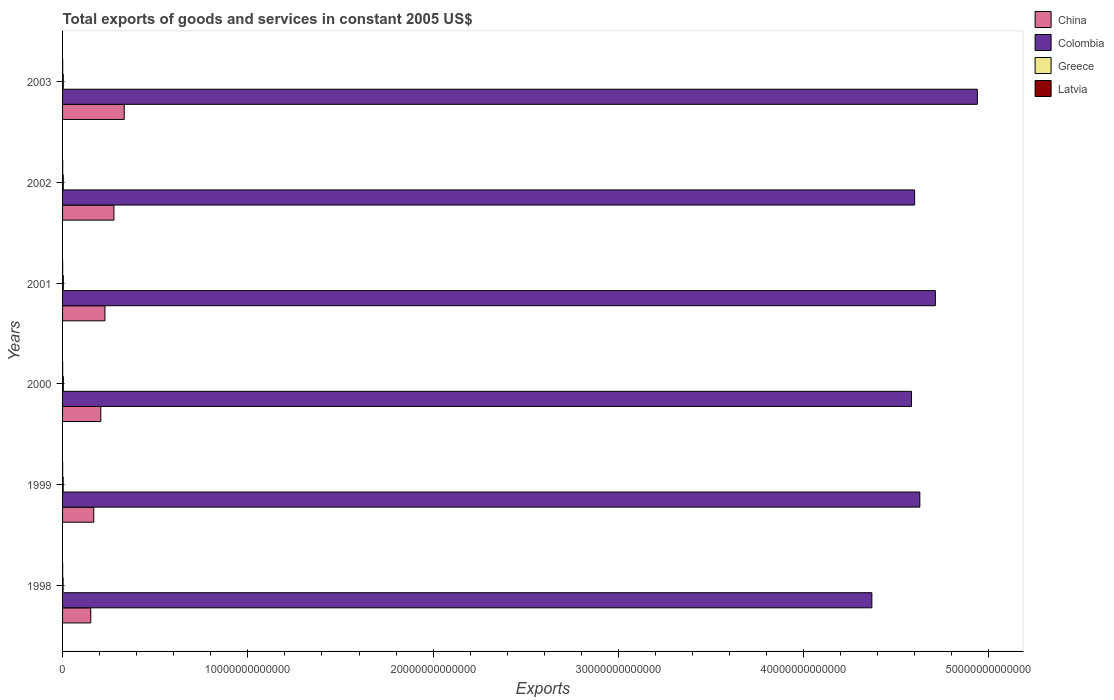How many different coloured bars are there?
Make the answer very short. 4. Are the number of bars per tick equal to the number of legend labels?
Offer a terse response. Yes. Are the number of bars on each tick of the Y-axis equal?
Your answer should be very brief. Yes. How many bars are there on the 3rd tick from the bottom?
Offer a very short reply. 4. What is the label of the 4th group of bars from the top?
Keep it short and to the point. 2000. In how many cases, is the number of bars for a given year not equal to the number of legend labels?
Make the answer very short. 0. What is the total exports of goods and services in China in 2001?
Your answer should be compact. 2.29e+12. Across all years, what is the maximum total exports of goods and services in Colombia?
Offer a very short reply. 4.94e+13. Across all years, what is the minimum total exports of goods and services in Colombia?
Offer a very short reply. 4.37e+13. In which year was the total exports of goods and services in China maximum?
Keep it short and to the point. 2003. What is the total total exports of goods and services in Latvia in the graph?
Provide a short and direct response. 2.90e+1. What is the difference between the total exports of goods and services in Greece in 2000 and that in 2001?
Your answer should be compact. -5.17e+07. What is the difference between the total exports of goods and services in Colombia in 2000 and the total exports of goods and services in Greece in 1998?
Provide a short and direct response. 4.58e+13. What is the average total exports of goods and services in China per year?
Offer a very short reply. 2.28e+12. In the year 2001, what is the difference between the total exports of goods and services in Colombia and total exports of goods and services in China?
Give a very brief answer. 4.48e+13. What is the ratio of the total exports of goods and services in Greece in 1998 to that in 2002?
Your answer should be compact. 0.71. Is the total exports of goods and services in China in 1999 less than that in 2003?
Keep it short and to the point. Yes. What is the difference between the highest and the second highest total exports of goods and services in Latvia?
Ensure brevity in your answer.  2.12e+08. What is the difference between the highest and the lowest total exports of goods and services in China?
Ensure brevity in your answer.  1.81e+12. How many years are there in the graph?
Your answer should be very brief. 6. What is the difference between two consecutive major ticks on the X-axis?
Give a very brief answer. 1.00e+13. Are the values on the major ticks of X-axis written in scientific E-notation?
Offer a terse response. No. How many legend labels are there?
Provide a short and direct response. 4. What is the title of the graph?
Keep it short and to the point. Total exports of goods and services in constant 2005 US$. Does "Ghana" appear as one of the legend labels in the graph?
Ensure brevity in your answer.  No. What is the label or title of the X-axis?
Your response must be concise. Exports. What is the label or title of the Y-axis?
Provide a short and direct response. Years. What is the Exports of China in 1998?
Provide a short and direct response. 1.52e+12. What is the Exports of Colombia in 1998?
Provide a short and direct response. 4.37e+13. What is the Exports in Greece in 1998?
Ensure brevity in your answer.  2.83e+1. What is the Exports in Latvia in 1998?
Offer a very short reply. 4.34e+09. What is the Exports in China in 1999?
Offer a terse response. 1.68e+12. What is the Exports in Colombia in 1999?
Provide a short and direct response. 4.63e+13. What is the Exports of Greece in 1999?
Make the answer very short. 3.52e+1. What is the Exports in Latvia in 1999?
Your answer should be very brief. 4.07e+09. What is the Exports in China in 2000?
Provide a short and direct response. 2.06e+12. What is the Exports in Colombia in 2000?
Keep it short and to the point. 4.58e+13. What is the Exports in Greece in 2000?
Your response must be concise. 4.30e+1. What is the Exports in Latvia in 2000?
Provide a succinct answer. 4.65e+09. What is the Exports of China in 2001?
Your answer should be very brief. 2.29e+12. What is the Exports in Colombia in 2001?
Your response must be concise. 4.71e+13. What is the Exports of Greece in 2001?
Your answer should be very brief. 4.31e+1. What is the Exports in Latvia in 2001?
Your answer should be very brief. 5.07e+09. What is the Exports in China in 2002?
Ensure brevity in your answer.  2.77e+12. What is the Exports of Colombia in 2002?
Provide a short and direct response. 4.60e+13. What is the Exports of Greece in 2002?
Offer a very short reply. 3.99e+1. What is the Exports in Latvia in 2002?
Offer a very short reply. 5.33e+09. What is the Exports of China in 2003?
Offer a terse response. 3.33e+12. What is the Exports of Colombia in 2003?
Keep it short and to the point. 4.94e+13. What is the Exports in Greece in 2003?
Provide a succinct answer. 3.96e+1. What is the Exports in Latvia in 2003?
Provide a succinct answer. 5.54e+09. Across all years, what is the maximum Exports of China?
Ensure brevity in your answer.  3.33e+12. Across all years, what is the maximum Exports of Colombia?
Keep it short and to the point. 4.94e+13. Across all years, what is the maximum Exports of Greece?
Provide a succinct answer. 4.31e+1. Across all years, what is the maximum Exports in Latvia?
Your answer should be very brief. 5.54e+09. Across all years, what is the minimum Exports of China?
Make the answer very short. 1.52e+12. Across all years, what is the minimum Exports of Colombia?
Your answer should be compact. 4.37e+13. Across all years, what is the minimum Exports of Greece?
Your answer should be very brief. 2.83e+1. Across all years, what is the minimum Exports in Latvia?
Your answer should be compact. 4.07e+09. What is the total Exports in China in the graph?
Make the answer very short. 1.37e+13. What is the total Exports in Colombia in the graph?
Your answer should be very brief. 2.78e+14. What is the total Exports of Greece in the graph?
Your answer should be very brief. 2.29e+11. What is the total Exports of Latvia in the graph?
Your answer should be very brief. 2.90e+1. What is the difference between the Exports in China in 1998 and that in 1999?
Your answer should be very brief. -1.63e+11. What is the difference between the Exports of Colombia in 1998 and that in 1999?
Your response must be concise. -2.59e+12. What is the difference between the Exports in Greece in 1998 and that in 1999?
Your answer should be compact. -6.92e+09. What is the difference between the Exports of Latvia in 1998 and that in 1999?
Your answer should be very brief. 2.76e+08. What is the difference between the Exports in China in 1998 and that in 2000?
Provide a succinct answer. -5.42e+11. What is the difference between the Exports in Colombia in 1998 and that in 2000?
Provide a succinct answer. -2.14e+12. What is the difference between the Exports of Greece in 1998 and that in 2000?
Offer a very short reply. -1.47e+1. What is the difference between the Exports of Latvia in 1998 and that in 2000?
Keep it short and to the point. -3.11e+08. What is the difference between the Exports in China in 1998 and that in 2001?
Give a very brief answer. -7.67e+11. What is the difference between the Exports in Colombia in 1998 and that in 2001?
Keep it short and to the point. -3.43e+12. What is the difference between the Exports in Greece in 1998 and that in 2001?
Provide a short and direct response. -1.48e+1. What is the difference between the Exports of Latvia in 1998 and that in 2001?
Keep it short and to the point. -7.31e+08. What is the difference between the Exports of China in 1998 and that in 2002?
Provide a succinct answer. -1.25e+12. What is the difference between the Exports in Colombia in 1998 and that in 2002?
Offer a very short reply. -2.31e+12. What is the difference between the Exports of Greece in 1998 and that in 2002?
Your response must be concise. -1.16e+1. What is the difference between the Exports in Latvia in 1998 and that in 2002?
Offer a terse response. -9.86e+08. What is the difference between the Exports of China in 1998 and that in 2003?
Provide a succinct answer. -1.81e+12. What is the difference between the Exports in Colombia in 1998 and that in 2003?
Your response must be concise. -5.69e+12. What is the difference between the Exports of Greece in 1998 and that in 2003?
Keep it short and to the point. -1.13e+1. What is the difference between the Exports in Latvia in 1998 and that in 2003?
Provide a short and direct response. -1.20e+09. What is the difference between the Exports of China in 1999 and that in 2000?
Your answer should be very brief. -3.80e+11. What is the difference between the Exports in Colombia in 1999 and that in 2000?
Provide a short and direct response. 4.48e+11. What is the difference between the Exports of Greece in 1999 and that in 2000?
Ensure brevity in your answer.  -7.81e+09. What is the difference between the Exports in Latvia in 1999 and that in 2000?
Give a very brief answer. -5.86e+08. What is the difference between the Exports in China in 1999 and that in 2001?
Your answer should be very brief. -6.04e+11. What is the difference between the Exports of Colombia in 1999 and that in 2001?
Give a very brief answer. -8.40e+11. What is the difference between the Exports in Greece in 1999 and that in 2001?
Keep it short and to the point. -7.86e+09. What is the difference between the Exports in Latvia in 1999 and that in 2001?
Keep it short and to the point. -1.01e+09. What is the difference between the Exports in China in 1999 and that in 2002?
Offer a terse response. -1.09e+12. What is the difference between the Exports of Colombia in 1999 and that in 2002?
Provide a short and direct response. 2.80e+11. What is the difference between the Exports in Greece in 1999 and that in 2002?
Give a very brief answer. -4.71e+09. What is the difference between the Exports of Latvia in 1999 and that in 2002?
Give a very brief answer. -1.26e+09. What is the difference between the Exports of China in 1999 and that in 2003?
Make the answer very short. -1.65e+12. What is the difference between the Exports of Colombia in 1999 and that in 2003?
Keep it short and to the point. -3.10e+12. What is the difference between the Exports of Greece in 1999 and that in 2003?
Your answer should be compact. -4.42e+09. What is the difference between the Exports of Latvia in 1999 and that in 2003?
Make the answer very short. -1.47e+09. What is the difference between the Exports of China in 2000 and that in 2001?
Provide a succinct answer. -2.25e+11. What is the difference between the Exports of Colombia in 2000 and that in 2001?
Offer a terse response. -1.29e+12. What is the difference between the Exports of Greece in 2000 and that in 2001?
Provide a succinct answer. -5.17e+07. What is the difference between the Exports in Latvia in 2000 and that in 2001?
Your response must be concise. -4.20e+08. What is the difference between the Exports in China in 2000 and that in 2002?
Make the answer very short. -7.09e+11. What is the difference between the Exports in Colombia in 2000 and that in 2002?
Offer a very short reply. -1.68e+11. What is the difference between the Exports in Greece in 2000 and that in 2002?
Provide a succinct answer. 3.10e+09. What is the difference between the Exports in Latvia in 2000 and that in 2002?
Make the answer very short. -6.76e+08. What is the difference between the Exports in China in 2000 and that in 2003?
Your response must be concise. -1.27e+12. What is the difference between the Exports of Colombia in 2000 and that in 2003?
Provide a succinct answer. -3.55e+12. What is the difference between the Exports of Greece in 2000 and that in 2003?
Provide a succinct answer. 3.40e+09. What is the difference between the Exports of Latvia in 2000 and that in 2003?
Make the answer very short. -8.88e+08. What is the difference between the Exports in China in 2001 and that in 2002?
Provide a succinct answer. -4.84e+11. What is the difference between the Exports in Colombia in 2001 and that in 2002?
Your response must be concise. 1.12e+12. What is the difference between the Exports in Greece in 2001 and that in 2002?
Give a very brief answer. 3.16e+09. What is the difference between the Exports in Latvia in 2001 and that in 2002?
Make the answer very short. -2.55e+08. What is the difference between the Exports in China in 2001 and that in 2003?
Ensure brevity in your answer.  -1.04e+12. What is the difference between the Exports of Colombia in 2001 and that in 2003?
Keep it short and to the point. -2.26e+12. What is the difference between the Exports in Greece in 2001 and that in 2003?
Offer a very short reply. 3.45e+09. What is the difference between the Exports in Latvia in 2001 and that in 2003?
Ensure brevity in your answer.  -4.67e+08. What is the difference between the Exports of China in 2002 and that in 2003?
Your answer should be very brief. -5.57e+11. What is the difference between the Exports of Colombia in 2002 and that in 2003?
Provide a succinct answer. -3.38e+12. What is the difference between the Exports in Greece in 2002 and that in 2003?
Offer a terse response. 2.93e+08. What is the difference between the Exports of Latvia in 2002 and that in 2003?
Ensure brevity in your answer.  -2.12e+08. What is the difference between the Exports in China in 1998 and the Exports in Colombia in 1999?
Offer a terse response. -4.47e+13. What is the difference between the Exports in China in 1998 and the Exports in Greece in 1999?
Your answer should be compact. 1.49e+12. What is the difference between the Exports of China in 1998 and the Exports of Latvia in 1999?
Keep it short and to the point. 1.52e+12. What is the difference between the Exports in Colombia in 1998 and the Exports in Greece in 1999?
Keep it short and to the point. 4.36e+13. What is the difference between the Exports of Colombia in 1998 and the Exports of Latvia in 1999?
Your response must be concise. 4.37e+13. What is the difference between the Exports in Greece in 1998 and the Exports in Latvia in 1999?
Provide a succinct answer. 2.42e+1. What is the difference between the Exports of China in 1998 and the Exports of Colombia in 2000?
Offer a very short reply. -4.43e+13. What is the difference between the Exports of China in 1998 and the Exports of Greece in 2000?
Your response must be concise. 1.48e+12. What is the difference between the Exports in China in 1998 and the Exports in Latvia in 2000?
Provide a succinct answer. 1.52e+12. What is the difference between the Exports of Colombia in 1998 and the Exports of Greece in 2000?
Your answer should be compact. 4.36e+13. What is the difference between the Exports of Colombia in 1998 and the Exports of Latvia in 2000?
Ensure brevity in your answer.  4.37e+13. What is the difference between the Exports in Greece in 1998 and the Exports in Latvia in 2000?
Your answer should be very brief. 2.36e+1. What is the difference between the Exports in China in 1998 and the Exports in Colombia in 2001?
Give a very brief answer. -4.56e+13. What is the difference between the Exports in China in 1998 and the Exports in Greece in 2001?
Your response must be concise. 1.48e+12. What is the difference between the Exports in China in 1998 and the Exports in Latvia in 2001?
Keep it short and to the point. 1.52e+12. What is the difference between the Exports in Colombia in 1998 and the Exports in Greece in 2001?
Your answer should be compact. 4.36e+13. What is the difference between the Exports in Colombia in 1998 and the Exports in Latvia in 2001?
Ensure brevity in your answer.  4.37e+13. What is the difference between the Exports of Greece in 1998 and the Exports of Latvia in 2001?
Provide a succinct answer. 2.32e+1. What is the difference between the Exports in China in 1998 and the Exports in Colombia in 2002?
Provide a succinct answer. -4.45e+13. What is the difference between the Exports of China in 1998 and the Exports of Greece in 2002?
Keep it short and to the point. 1.48e+12. What is the difference between the Exports of China in 1998 and the Exports of Latvia in 2002?
Your answer should be very brief. 1.52e+12. What is the difference between the Exports in Colombia in 1998 and the Exports in Greece in 2002?
Ensure brevity in your answer.  4.36e+13. What is the difference between the Exports in Colombia in 1998 and the Exports in Latvia in 2002?
Keep it short and to the point. 4.37e+13. What is the difference between the Exports of Greece in 1998 and the Exports of Latvia in 2002?
Keep it short and to the point. 2.30e+1. What is the difference between the Exports in China in 1998 and the Exports in Colombia in 2003?
Provide a short and direct response. -4.79e+13. What is the difference between the Exports of China in 1998 and the Exports of Greece in 2003?
Provide a succinct answer. 1.48e+12. What is the difference between the Exports of China in 1998 and the Exports of Latvia in 2003?
Offer a terse response. 1.52e+12. What is the difference between the Exports of Colombia in 1998 and the Exports of Greece in 2003?
Your answer should be compact. 4.36e+13. What is the difference between the Exports of Colombia in 1998 and the Exports of Latvia in 2003?
Offer a very short reply. 4.37e+13. What is the difference between the Exports in Greece in 1998 and the Exports in Latvia in 2003?
Ensure brevity in your answer.  2.28e+1. What is the difference between the Exports of China in 1999 and the Exports of Colombia in 2000?
Give a very brief answer. -4.41e+13. What is the difference between the Exports in China in 1999 and the Exports in Greece in 2000?
Offer a terse response. 1.64e+12. What is the difference between the Exports in China in 1999 and the Exports in Latvia in 2000?
Provide a succinct answer. 1.68e+12. What is the difference between the Exports of Colombia in 1999 and the Exports of Greece in 2000?
Provide a succinct answer. 4.62e+13. What is the difference between the Exports in Colombia in 1999 and the Exports in Latvia in 2000?
Offer a terse response. 4.63e+13. What is the difference between the Exports in Greece in 1999 and the Exports in Latvia in 2000?
Your response must be concise. 3.06e+1. What is the difference between the Exports in China in 1999 and the Exports in Colombia in 2001?
Make the answer very short. -4.54e+13. What is the difference between the Exports in China in 1999 and the Exports in Greece in 2001?
Your answer should be compact. 1.64e+12. What is the difference between the Exports of China in 1999 and the Exports of Latvia in 2001?
Give a very brief answer. 1.68e+12. What is the difference between the Exports in Colombia in 1999 and the Exports in Greece in 2001?
Your answer should be very brief. 4.62e+13. What is the difference between the Exports of Colombia in 1999 and the Exports of Latvia in 2001?
Your answer should be very brief. 4.63e+13. What is the difference between the Exports of Greece in 1999 and the Exports of Latvia in 2001?
Ensure brevity in your answer.  3.01e+1. What is the difference between the Exports of China in 1999 and the Exports of Colombia in 2002?
Provide a short and direct response. -4.43e+13. What is the difference between the Exports in China in 1999 and the Exports in Greece in 2002?
Your response must be concise. 1.64e+12. What is the difference between the Exports of China in 1999 and the Exports of Latvia in 2002?
Offer a terse response. 1.68e+12. What is the difference between the Exports of Colombia in 1999 and the Exports of Greece in 2002?
Your answer should be very brief. 4.62e+13. What is the difference between the Exports in Colombia in 1999 and the Exports in Latvia in 2002?
Keep it short and to the point. 4.63e+13. What is the difference between the Exports in Greece in 1999 and the Exports in Latvia in 2002?
Ensure brevity in your answer.  2.99e+1. What is the difference between the Exports in China in 1999 and the Exports in Colombia in 2003?
Your answer should be compact. -4.77e+13. What is the difference between the Exports of China in 1999 and the Exports of Greece in 2003?
Give a very brief answer. 1.64e+12. What is the difference between the Exports of China in 1999 and the Exports of Latvia in 2003?
Keep it short and to the point. 1.68e+12. What is the difference between the Exports in Colombia in 1999 and the Exports in Greece in 2003?
Provide a succinct answer. 4.62e+13. What is the difference between the Exports of Colombia in 1999 and the Exports of Latvia in 2003?
Offer a very short reply. 4.63e+13. What is the difference between the Exports of Greece in 1999 and the Exports of Latvia in 2003?
Your answer should be compact. 2.97e+1. What is the difference between the Exports of China in 2000 and the Exports of Colombia in 2001?
Your answer should be compact. -4.50e+13. What is the difference between the Exports of China in 2000 and the Exports of Greece in 2001?
Keep it short and to the point. 2.02e+12. What is the difference between the Exports of China in 2000 and the Exports of Latvia in 2001?
Offer a terse response. 2.06e+12. What is the difference between the Exports of Colombia in 2000 and the Exports of Greece in 2001?
Your answer should be very brief. 4.58e+13. What is the difference between the Exports in Colombia in 2000 and the Exports in Latvia in 2001?
Your answer should be very brief. 4.58e+13. What is the difference between the Exports of Greece in 2000 and the Exports of Latvia in 2001?
Ensure brevity in your answer.  3.80e+1. What is the difference between the Exports of China in 2000 and the Exports of Colombia in 2002?
Keep it short and to the point. -4.39e+13. What is the difference between the Exports of China in 2000 and the Exports of Greece in 2002?
Keep it short and to the point. 2.02e+12. What is the difference between the Exports of China in 2000 and the Exports of Latvia in 2002?
Offer a terse response. 2.06e+12. What is the difference between the Exports of Colombia in 2000 and the Exports of Greece in 2002?
Your response must be concise. 4.58e+13. What is the difference between the Exports of Colombia in 2000 and the Exports of Latvia in 2002?
Offer a very short reply. 4.58e+13. What is the difference between the Exports in Greece in 2000 and the Exports in Latvia in 2002?
Keep it short and to the point. 3.77e+1. What is the difference between the Exports in China in 2000 and the Exports in Colombia in 2003?
Your answer should be compact. -4.73e+13. What is the difference between the Exports of China in 2000 and the Exports of Greece in 2003?
Offer a terse response. 2.02e+12. What is the difference between the Exports in China in 2000 and the Exports in Latvia in 2003?
Your answer should be very brief. 2.06e+12. What is the difference between the Exports in Colombia in 2000 and the Exports in Greece in 2003?
Offer a very short reply. 4.58e+13. What is the difference between the Exports of Colombia in 2000 and the Exports of Latvia in 2003?
Keep it short and to the point. 4.58e+13. What is the difference between the Exports of Greece in 2000 and the Exports of Latvia in 2003?
Make the answer very short. 3.75e+1. What is the difference between the Exports in China in 2001 and the Exports in Colombia in 2002?
Ensure brevity in your answer.  -4.37e+13. What is the difference between the Exports of China in 2001 and the Exports of Greece in 2002?
Offer a terse response. 2.25e+12. What is the difference between the Exports of China in 2001 and the Exports of Latvia in 2002?
Keep it short and to the point. 2.28e+12. What is the difference between the Exports of Colombia in 2001 and the Exports of Greece in 2002?
Your answer should be compact. 4.71e+13. What is the difference between the Exports of Colombia in 2001 and the Exports of Latvia in 2002?
Offer a terse response. 4.71e+13. What is the difference between the Exports in Greece in 2001 and the Exports in Latvia in 2002?
Give a very brief answer. 3.78e+1. What is the difference between the Exports in China in 2001 and the Exports in Colombia in 2003?
Offer a terse response. -4.71e+13. What is the difference between the Exports of China in 2001 and the Exports of Greece in 2003?
Make the answer very short. 2.25e+12. What is the difference between the Exports of China in 2001 and the Exports of Latvia in 2003?
Offer a very short reply. 2.28e+12. What is the difference between the Exports of Colombia in 2001 and the Exports of Greece in 2003?
Provide a short and direct response. 4.71e+13. What is the difference between the Exports in Colombia in 2001 and the Exports in Latvia in 2003?
Offer a terse response. 4.71e+13. What is the difference between the Exports of Greece in 2001 and the Exports of Latvia in 2003?
Make the answer very short. 3.75e+1. What is the difference between the Exports of China in 2002 and the Exports of Colombia in 2003?
Provide a succinct answer. -4.66e+13. What is the difference between the Exports in China in 2002 and the Exports in Greece in 2003?
Provide a short and direct response. 2.73e+12. What is the difference between the Exports of China in 2002 and the Exports of Latvia in 2003?
Your answer should be very brief. 2.77e+12. What is the difference between the Exports of Colombia in 2002 and the Exports of Greece in 2003?
Offer a very short reply. 4.60e+13. What is the difference between the Exports of Colombia in 2002 and the Exports of Latvia in 2003?
Your answer should be compact. 4.60e+13. What is the difference between the Exports in Greece in 2002 and the Exports in Latvia in 2003?
Ensure brevity in your answer.  3.44e+1. What is the average Exports in China per year?
Provide a short and direct response. 2.28e+12. What is the average Exports of Colombia per year?
Give a very brief answer. 4.64e+13. What is the average Exports of Greece per year?
Give a very brief answer. 3.82e+1. What is the average Exports in Latvia per year?
Give a very brief answer. 4.83e+09. In the year 1998, what is the difference between the Exports of China and Exports of Colombia?
Offer a very short reply. -4.22e+13. In the year 1998, what is the difference between the Exports of China and Exports of Greece?
Provide a short and direct response. 1.49e+12. In the year 1998, what is the difference between the Exports in China and Exports in Latvia?
Ensure brevity in your answer.  1.52e+12. In the year 1998, what is the difference between the Exports of Colombia and Exports of Greece?
Provide a succinct answer. 4.37e+13. In the year 1998, what is the difference between the Exports of Colombia and Exports of Latvia?
Your answer should be compact. 4.37e+13. In the year 1998, what is the difference between the Exports of Greece and Exports of Latvia?
Ensure brevity in your answer.  2.40e+1. In the year 1999, what is the difference between the Exports in China and Exports in Colombia?
Your answer should be compact. -4.46e+13. In the year 1999, what is the difference between the Exports in China and Exports in Greece?
Your answer should be compact. 1.65e+12. In the year 1999, what is the difference between the Exports of China and Exports of Latvia?
Provide a succinct answer. 1.68e+12. In the year 1999, what is the difference between the Exports in Colombia and Exports in Greece?
Make the answer very short. 4.62e+13. In the year 1999, what is the difference between the Exports of Colombia and Exports of Latvia?
Offer a terse response. 4.63e+13. In the year 1999, what is the difference between the Exports of Greece and Exports of Latvia?
Provide a short and direct response. 3.12e+1. In the year 2000, what is the difference between the Exports of China and Exports of Colombia?
Your answer should be compact. -4.38e+13. In the year 2000, what is the difference between the Exports in China and Exports in Greece?
Provide a short and direct response. 2.02e+12. In the year 2000, what is the difference between the Exports in China and Exports in Latvia?
Provide a succinct answer. 2.06e+12. In the year 2000, what is the difference between the Exports in Colombia and Exports in Greece?
Your answer should be very brief. 4.58e+13. In the year 2000, what is the difference between the Exports of Colombia and Exports of Latvia?
Your answer should be compact. 4.58e+13. In the year 2000, what is the difference between the Exports of Greece and Exports of Latvia?
Provide a short and direct response. 3.84e+1. In the year 2001, what is the difference between the Exports of China and Exports of Colombia?
Give a very brief answer. -4.48e+13. In the year 2001, what is the difference between the Exports in China and Exports in Greece?
Offer a terse response. 2.25e+12. In the year 2001, what is the difference between the Exports of China and Exports of Latvia?
Give a very brief answer. 2.28e+12. In the year 2001, what is the difference between the Exports in Colombia and Exports in Greece?
Your answer should be very brief. 4.71e+13. In the year 2001, what is the difference between the Exports in Colombia and Exports in Latvia?
Make the answer very short. 4.71e+13. In the year 2001, what is the difference between the Exports of Greece and Exports of Latvia?
Keep it short and to the point. 3.80e+1. In the year 2002, what is the difference between the Exports of China and Exports of Colombia?
Your response must be concise. -4.32e+13. In the year 2002, what is the difference between the Exports of China and Exports of Greece?
Give a very brief answer. 2.73e+12. In the year 2002, what is the difference between the Exports in China and Exports in Latvia?
Offer a very short reply. 2.77e+12. In the year 2002, what is the difference between the Exports in Colombia and Exports in Greece?
Provide a short and direct response. 4.60e+13. In the year 2002, what is the difference between the Exports of Colombia and Exports of Latvia?
Offer a terse response. 4.60e+13. In the year 2002, what is the difference between the Exports in Greece and Exports in Latvia?
Your answer should be compact. 3.46e+1. In the year 2003, what is the difference between the Exports in China and Exports in Colombia?
Make the answer very short. -4.60e+13. In the year 2003, what is the difference between the Exports in China and Exports in Greece?
Your response must be concise. 3.29e+12. In the year 2003, what is the difference between the Exports of China and Exports of Latvia?
Ensure brevity in your answer.  3.32e+12. In the year 2003, what is the difference between the Exports in Colombia and Exports in Greece?
Ensure brevity in your answer.  4.93e+13. In the year 2003, what is the difference between the Exports in Colombia and Exports in Latvia?
Provide a succinct answer. 4.94e+13. In the year 2003, what is the difference between the Exports of Greece and Exports of Latvia?
Your answer should be very brief. 3.41e+1. What is the ratio of the Exports of China in 1998 to that in 1999?
Offer a very short reply. 0.9. What is the ratio of the Exports of Colombia in 1998 to that in 1999?
Offer a very short reply. 0.94. What is the ratio of the Exports of Greece in 1998 to that in 1999?
Provide a succinct answer. 0.8. What is the ratio of the Exports of Latvia in 1998 to that in 1999?
Keep it short and to the point. 1.07. What is the ratio of the Exports in China in 1998 to that in 2000?
Your response must be concise. 0.74. What is the ratio of the Exports in Colombia in 1998 to that in 2000?
Make the answer very short. 0.95. What is the ratio of the Exports in Greece in 1998 to that in 2000?
Your answer should be very brief. 0.66. What is the ratio of the Exports in Latvia in 1998 to that in 2000?
Give a very brief answer. 0.93. What is the ratio of the Exports of China in 1998 to that in 2001?
Offer a terse response. 0.66. What is the ratio of the Exports of Colombia in 1998 to that in 2001?
Your answer should be very brief. 0.93. What is the ratio of the Exports of Greece in 1998 to that in 2001?
Ensure brevity in your answer.  0.66. What is the ratio of the Exports of Latvia in 1998 to that in 2001?
Your response must be concise. 0.86. What is the ratio of the Exports of China in 1998 to that in 2002?
Provide a succinct answer. 0.55. What is the ratio of the Exports in Colombia in 1998 to that in 2002?
Your response must be concise. 0.95. What is the ratio of the Exports in Greece in 1998 to that in 2002?
Provide a short and direct response. 0.71. What is the ratio of the Exports in Latvia in 1998 to that in 2002?
Provide a short and direct response. 0.81. What is the ratio of the Exports of China in 1998 to that in 2003?
Ensure brevity in your answer.  0.46. What is the ratio of the Exports in Colombia in 1998 to that in 2003?
Your answer should be very brief. 0.88. What is the ratio of the Exports in Greece in 1998 to that in 2003?
Give a very brief answer. 0.71. What is the ratio of the Exports of Latvia in 1998 to that in 2003?
Your answer should be compact. 0.78. What is the ratio of the Exports in China in 1999 to that in 2000?
Give a very brief answer. 0.82. What is the ratio of the Exports of Colombia in 1999 to that in 2000?
Offer a very short reply. 1.01. What is the ratio of the Exports in Greece in 1999 to that in 2000?
Offer a terse response. 0.82. What is the ratio of the Exports in Latvia in 1999 to that in 2000?
Provide a short and direct response. 0.87. What is the ratio of the Exports in China in 1999 to that in 2001?
Ensure brevity in your answer.  0.74. What is the ratio of the Exports of Colombia in 1999 to that in 2001?
Offer a terse response. 0.98. What is the ratio of the Exports in Greece in 1999 to that in 2001?
Your response must be concise. 0.82. What is the ratio of the Exports in Latvia in 1999 to that in 2001?
Make the answer very short. 0.8. What is the ratio of the Exports in China in 1999 to that in 2002?
Give a very brief answer. 0.61. What is the ratio of the Exports of Colombia in 1999 to that in 2002?
Keep it short and to the point. 1.01. What is the ratio of the Exports in Greece in 1999 to that in 2002?
Ensure brevity in your answer.  0.88. What is the ratio of the Exports in Latvia in 1999 to that in 2002?
Provide a succinct answer. 0.76. What is the ratio of the Exports in China in 1999 to that in 2003?
Offer a terse response. 0.51. What is the ratio of the Exports of Colombia in 1999 to that in 2003?
Provide a succinct answer. 0.94. What is the ratio of the Exports of Greece in 1999 to that in 2003?
Make the answer very short. 0.89. What is the ratio of the Exports in Latvia in 1999 to that in 2003?
Offer a terse response. 0.73. What is the ratio of the Exports in China in 2000 to that in 2001?
Provide a short and direct response. 0.9. What is the ratio of the Exports in Colombia in 2000 to that in 2001?
Provide a short and direct response. 0.97. What is the ratio of the Exports in Greece in 2000 to that in 2001?
Your response must be concise. 1. What is the ratio of the Exports of Latvia in 2000 to that in 2001?
Give a very brief answer. 0.92. What is the ratio of the Exports of China in 2000 to that in 2002?
Offer a very short reply. 0.74. What is the ratio of the Exports in Colombia in 2000 to that in 2002?
Provide a succinct answer. 1. What is the ratio of the Exports in Greece in 2000 to that in 2002?
Your answer should be compact. 1.08. What is the ratio of the Exports of Latvia in 2000 to that in 2002?
Your response must be concise. 0.87. What is the ratio of the Exports of China in 2000 to that in 2003?
Give a very brief answer. 0.62. What is the ratio of the Exports in Colombia in 2000 to that in 2003?
Your answer should be very brief. 0.93. What is the ratio of the Exports in Greece in 2000 to that in 2003?
Offer a terse response. 1.09. What is the ratio of the Exports of Latvia in 2000 to that in 2003?
Offer a very short reply. 0.84. What is the ratio of the Exports in China in 2001 to that in 2002?
Your answer should be very brief. 0.83. What is the ratio of the Exports in Colombia in 2001 to that in 2002?
Your answer should be very brief. 1.02. What is the ratio of the Exports in Greece in 2001 to that in 2002?
Your answer should be very brief. 1.08. What is the ratio of the Exports of Latvia in 2001 to that in 2002?
Ensure brevity in your answer.  0.95. What is the ratio of the Exports of China in 2001 to that in 2003?
Ensure brevity in your answer.  0.69. What is the ratio of the Exports in Colombia in 2001 to that in 2003?
Provide a short and direct response. 0.95. What is the ratio of the Exports of Greece in 2001 to that in 2003?
Keep it short and to the point. 1.09. What is the ratio of the Exports of Latvia in 2001 to that in 2003?
Give a very brief answer. 0.92. What is the ratio of the Exports in China in 2002 to that in 2003?
Provide a succinct answer. 0.83. What is the ratio of the Exports of Colombia in 2002 to that in 2003?
Offer a very short reply. 0.93. What is the ratio of the Exports of Greece in 2002 to that in 2003?
Your answer should be very brief. 1.01. What is the ratio of the Exports in Latvia in 2002 to that in 2003?
Keep it short and to the point. 0.96. What is the difference between the highest and the second highest Exports in China?
Your answer should be compact. 5.57e+11. What is the difference between the highest and the second highest Exports in Colombia?
Make the answer very short. 2.26e+12. What is the difference between the highest and the second highest Exports in Greece?
Offer a terse response. 5.17e+07. What is the difference between the highest and the second highest Exports in Latvia?
Your response must be concise. 2.12e+08. What is the difference between the highest and the lowest Exports of China?
Keep it short and to the point. 1.81e+12. What is the difference between the highest and the lowest Exports of Colombia?
Ensure brevity in your answer.  5.69e+12. What is the difference between the highest and the lowest Exports in Greece?
Provide a succinct answer. 1.48e+1. What is the difference between the highest and the lowest Exports in Latvia?
Give a very brief answer. 1.47e+09. 